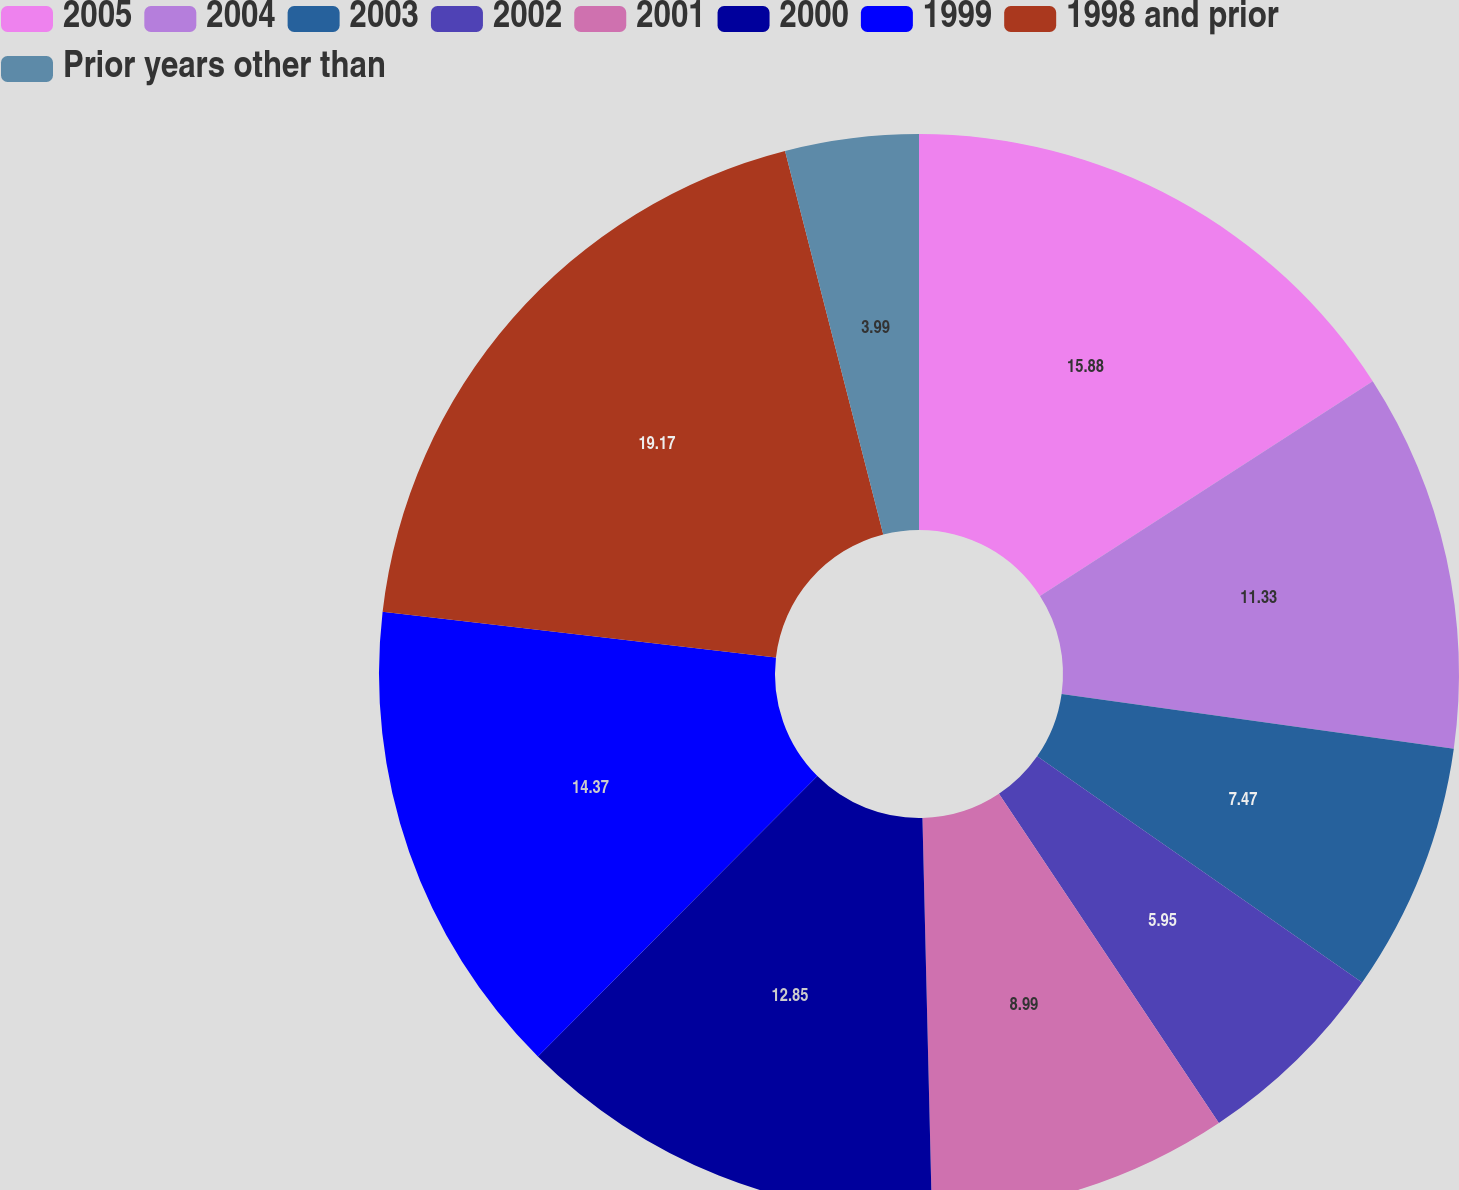Convert chart to OTSL. <chart><loc_0><loc_0><loc_500><loc_500><pie_chart><fcel>2005<fcel>2004<fcel>2003<fcel>2002<fcel>2001<fcel>2000<fcel>1999<fcel>1998 and prior<fcel>Prior years other than<nl><fcel>15.88%<fcel>11.33%<fcel>7.47%<fcel>5.95%<fcel>8.99%<fcel>12.85%<fcel>14.37%<fcel>19.17%<fcel>3.99%<nl></chart> 